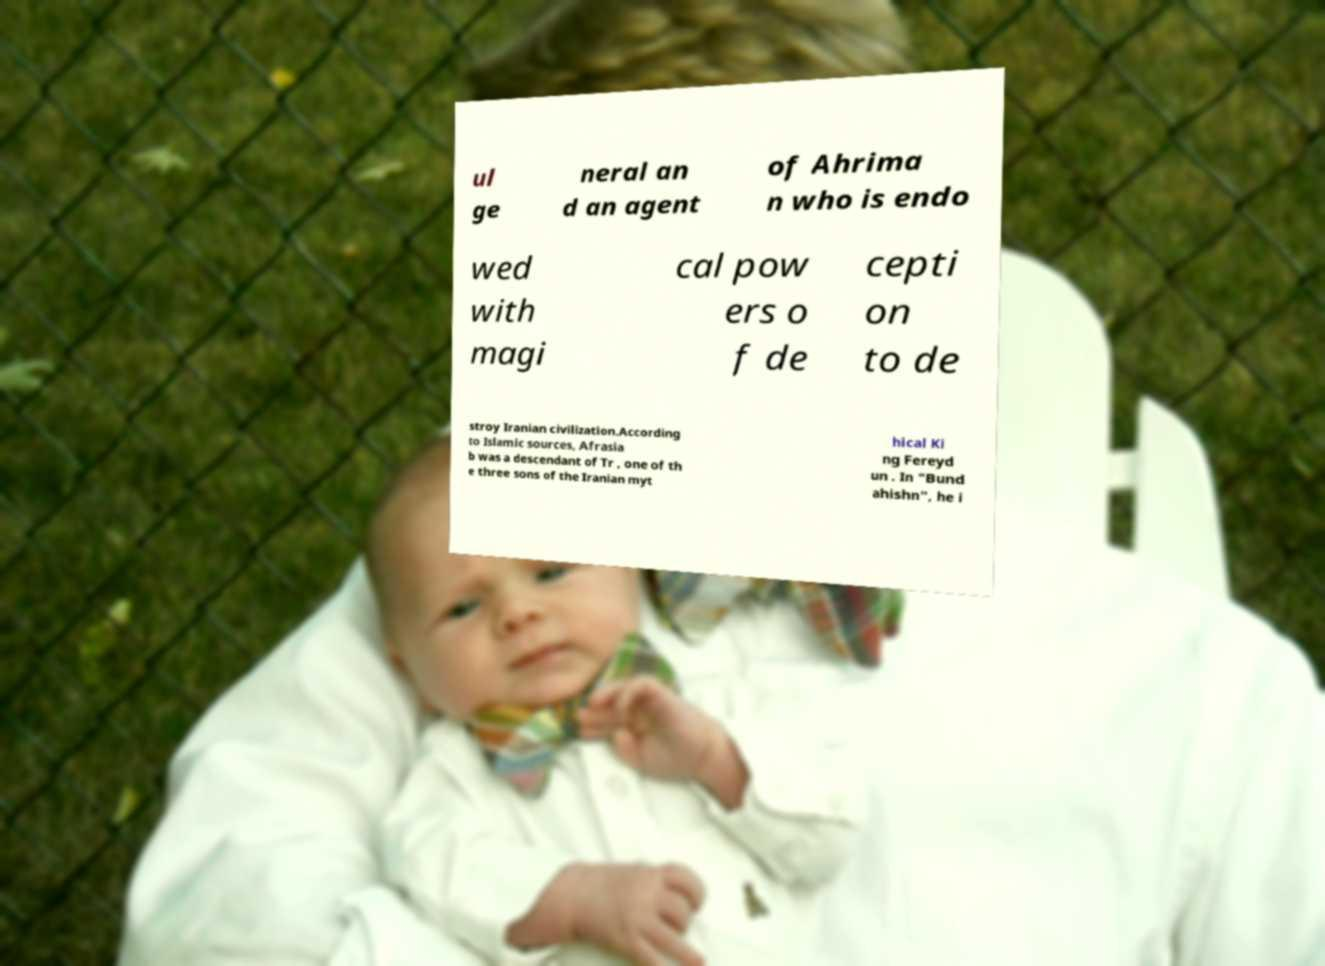What messages or text are displayed in this image? I need them in a readable, typed format. ul ge neral an d an agent of Ahrima n who is endo wed with magi cal pow ers o f de cepti on to de stroy Iranian civilization.According to Islamic sources, Afrasia b was a descendant of Tr , one of th e three sons of the Iranian myt hical Ki ng Fereyd un . In "Bund ahishn", he i 